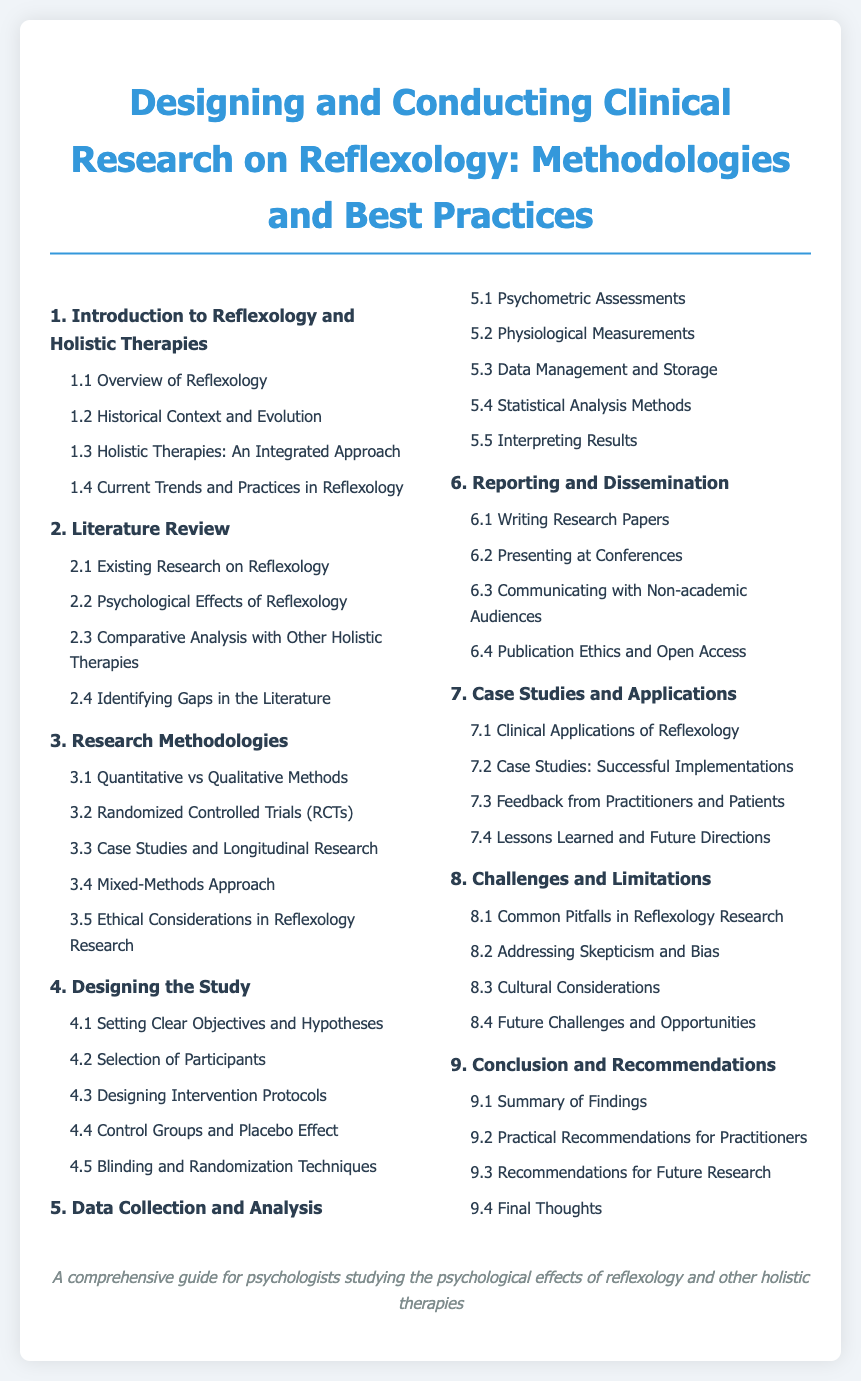What is the title of the document? The title is mentioned at the top of the document, which is "Designing and Conducting Clinical Research on Reflexology: Methodologies and Best Practices."
Answer: Designing and Conducting Clinical Research on Reflexology: Methodologies and Best Practices How many chapters are in the document? The number of chapters can be counted from the table of contents, which lists 9 chapters.
Answer: 9 What section discusses the psychological effects of reflexology? The section related to psychological effects can be found under chapter 2, specifically section 2.2.
Answer: 2.2 Psychological Effects of Reflexology What research methodology is compared to qualitative methods? The question looks for a specific section under chapter 3 that compares methodologies, which indicates "Quantitative" methods.
Answer: Quantitative Which chapter covers ethical considerations in reflexology research? The chapter related to ethical concerns is labeled as chapter 3, specifically section 3.5.
Answer: 3.5 Ethical Considerations in Reflexology Research What is the last section in the document? The last section can be found in chapter 9, which is labeled as 9.4.
Answer: 9.4 Final Thoughts 